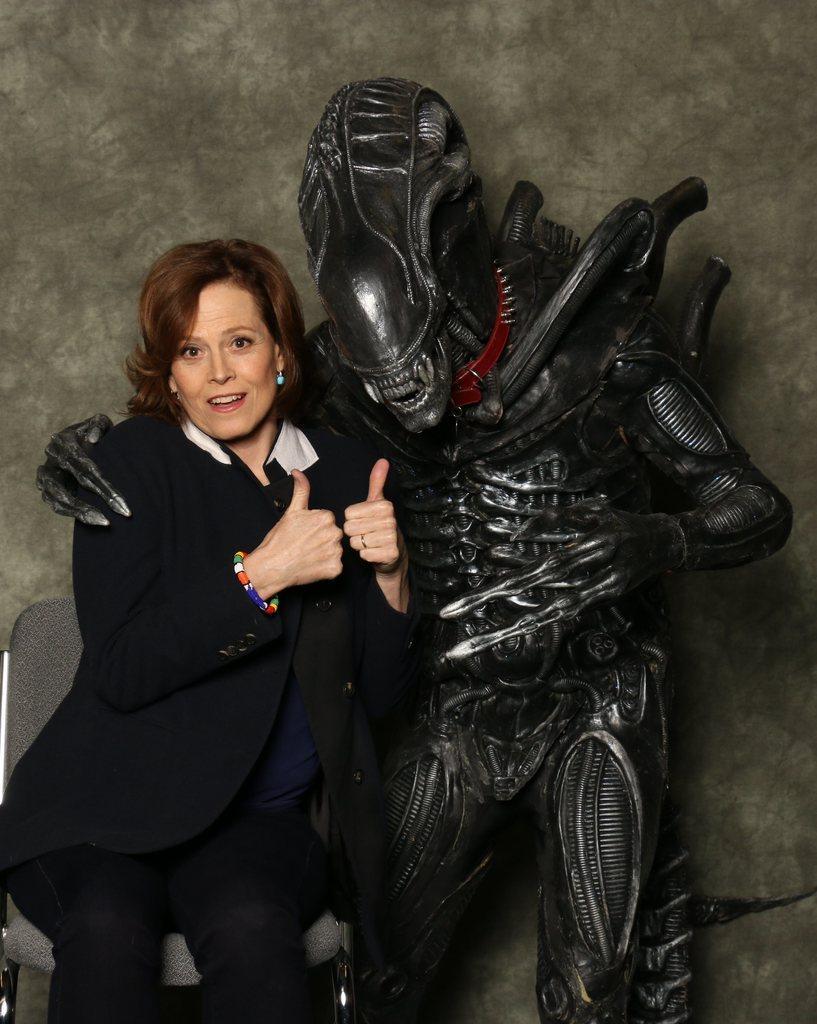Please provide a concise description of this image. In this image there is a woman in the middle who is keeping her thumbs up. Beside her there is a robot which kept its hand on her. In the background there is a wall. 